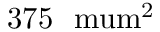Convert formula to latex. <formula><loc_0><loc_0><loc_500><loc_500>3 7 5 \ m u m ^ { 2 }</formula> 